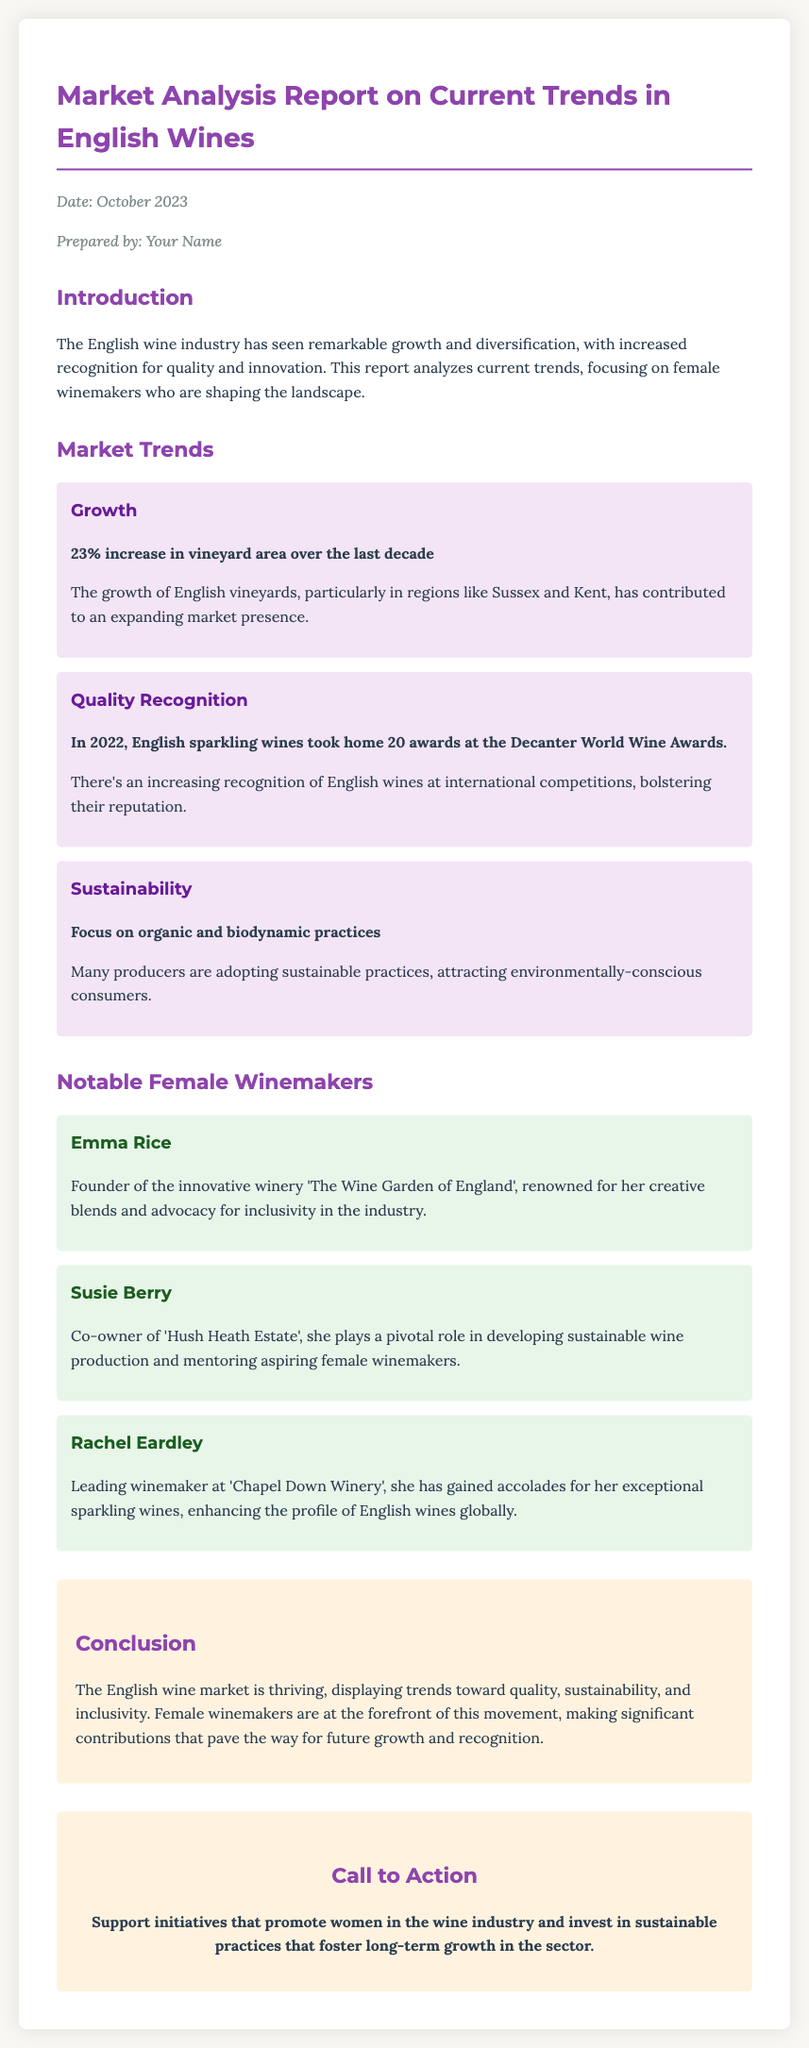What is the date of the report? The date is specified in the memo header as October 2023.
Answer: October 2023 Who is the founder of 'The Wine Garden of England'? The memo explicitly states the founder is Emma Rice.
Answer: Emma Rice What percentage increase in vineyard area is reported? The report mentions a specific percentage increase of 23% in vineyard area over the last decade.
Answer: 23% What is the role of Susie Berry? The document highlights her position as co-owner of 'Hush Heath Estate' and her involvement in sustainable practices.
Answer: Co-owner Which area shows the most growth for English vineyards? The memo refers to Sussex and Kent as regions contributing to vineyard expansion.
Answer: Sussex and Kent How many awards did English sparkling wines win in 2022? The document states that English sparkling wines received 20 awards at the Decanter World Wine Awards in 2022.
Answer: 20 What is a key focus for many producers according to the trends? The report indicates a focus on organic and biodynamic practices as key aspects of sustainability.
Answer: Organic and biodynamic practices Name one notable achievement of Rachel Eardley. The memo describes her accolades for exceptional sparkling wines, enhancing English wine profiles.
Answer: Exceptional sparkling wines What is the conclusion regarding female winemakers in the report? The conclusion emphasizes their significant contributions to quality, sustainability, and inclusivity.
Answer: Significant contributions 